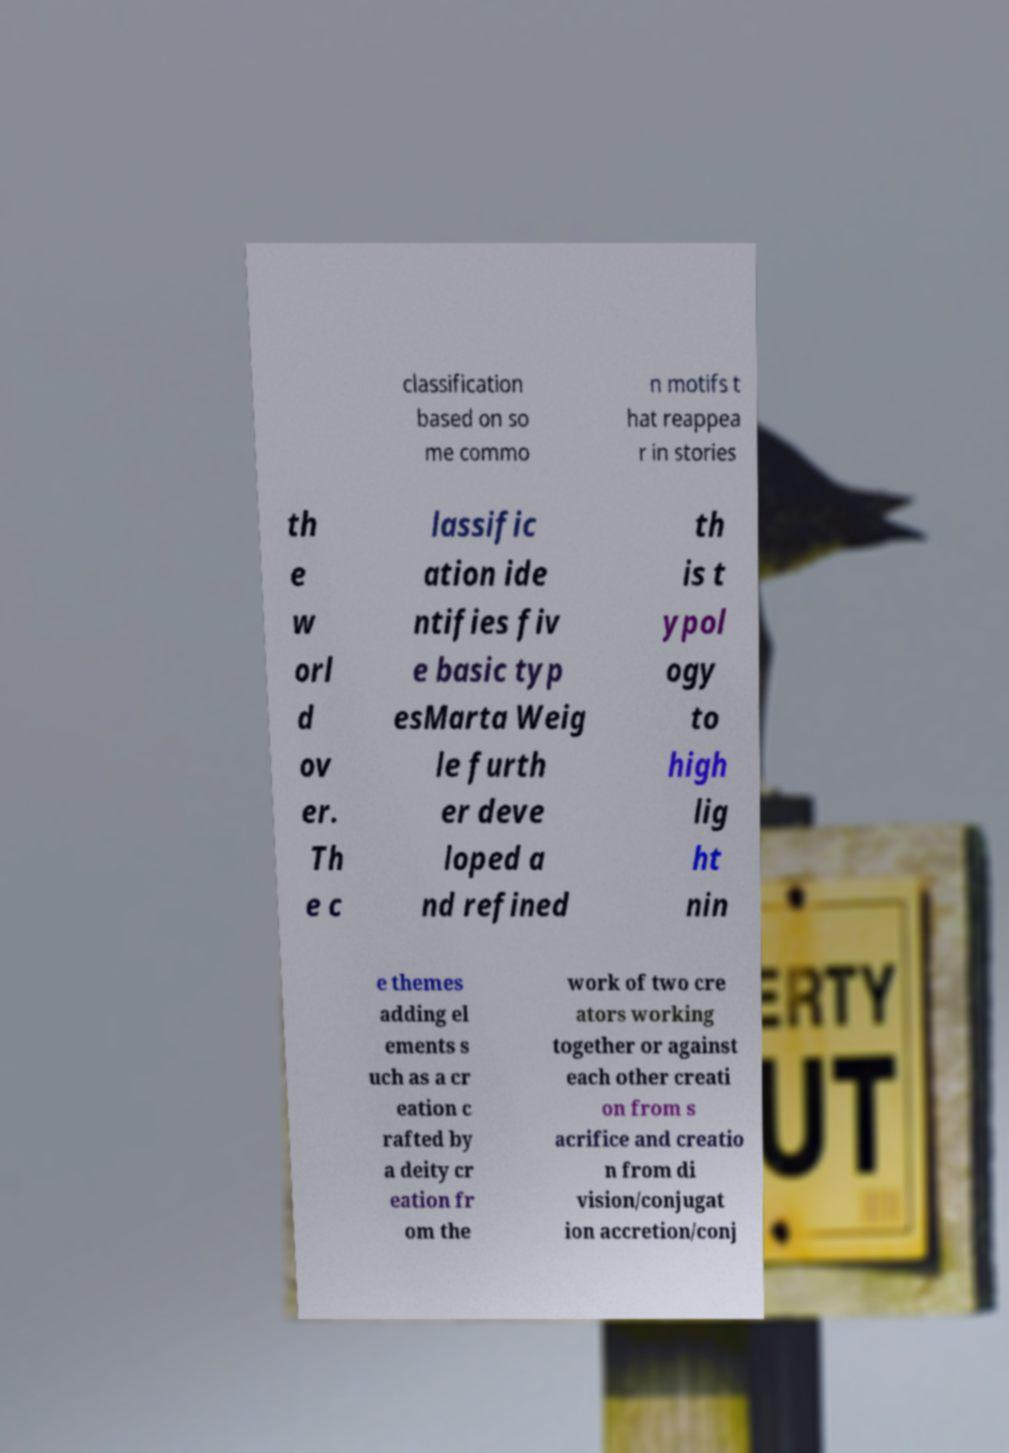For documentation purposes, I need the text within this image transcribed. Could you provide that? classification based on so me commo n motifs t hat reappea r in stories th e w orl d ov er. Th e c lassific ation ide ntifies fiv e basic typ esMarta Weig le furth er deve loped a nd refined th is t ypol ogy to high lig ht nin e themes adding el ements s uch as a cr eation c rafted by a deity cr eation fr om the work of two cre ators working together or against each other creati on from s acrifice and creatio n from di vision/conjugat ion accretion/conj 